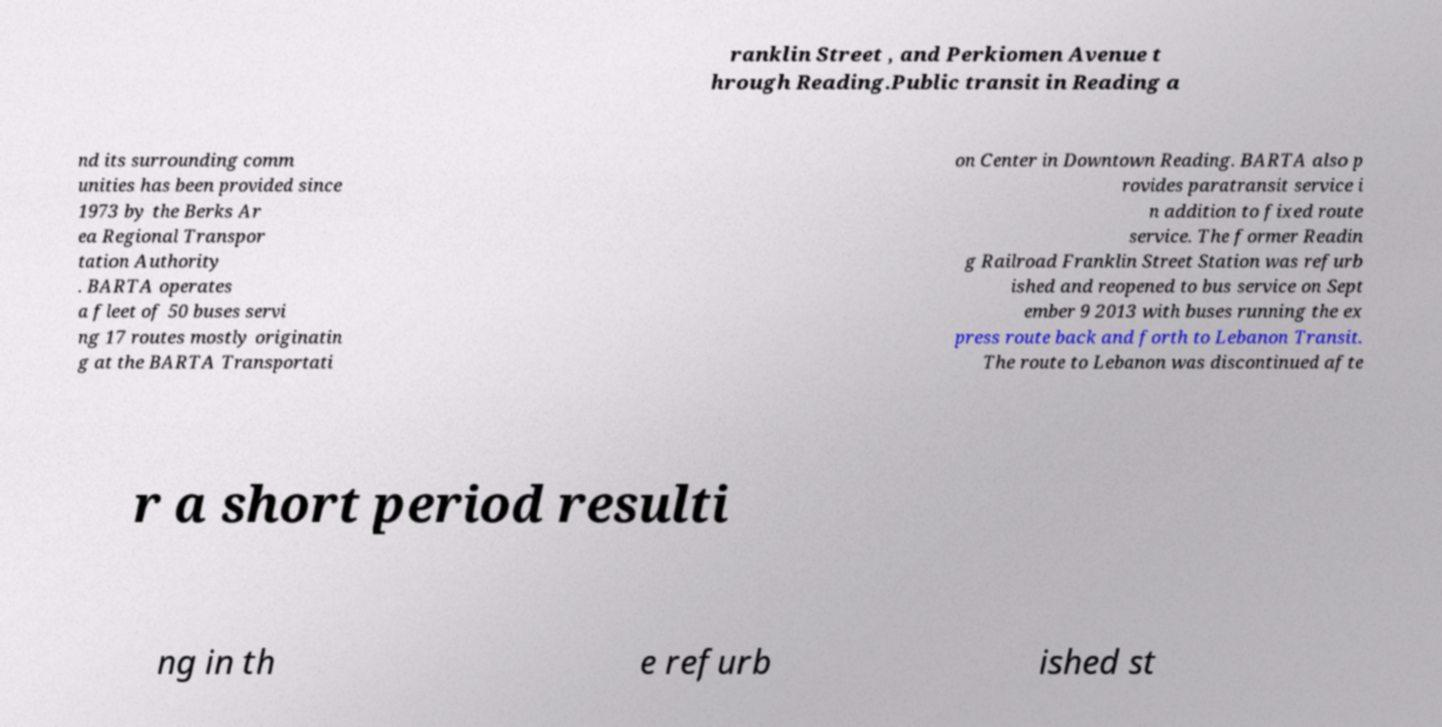Could you extract and type out the text from this image? ranklin Street , and Perkiomen Avenue t hrough Reading.Public transit in Reading a nd its surrounding comm unities has been provided since 1973 by the Berks Ar ea Regional Transpor tation Authority . BARTA operates a fleet of 50 buses servi ng 17 routes mostly originatin g at the BARTA Transportati on Center in Downtown Reading. BARTA also p rovides paratransit service i n addition to fixed route service. The former Readin g Railroad Franklin Street Station was refurb ished and reopened to bus service on Sept ember 9 2013 with buses running the ex press route back and forth to Lebanon Transit. The route to Lebanon was discontinued afte r a short period resulti ng in th e refurb ished st 